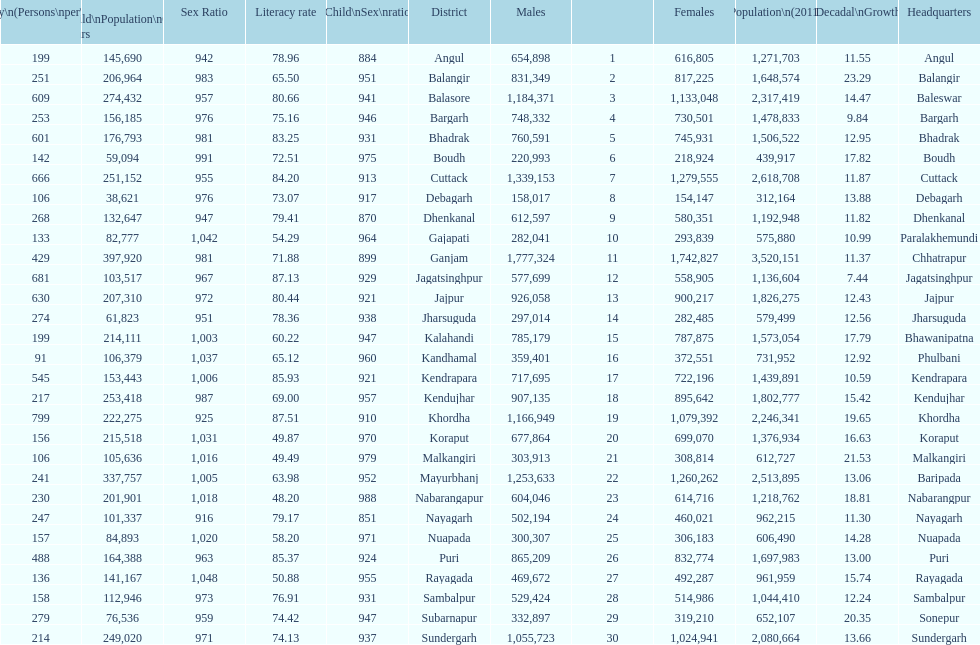How many females live in cuttack? 1,279,555. 